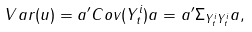Convert formula to latex. <formula><loc_0><loc_0><loc_500><loc_500>V a r ( { u } ) = { a } ^ { \prime } C o v ( { Y } _ { t } ^ { i } ) { a } = { a } ^ { \prime } { \Sigma } _ { { Y } _ { t } ^ { i } { Y } _ { t } ^ { i } } { a } ,</formula> 